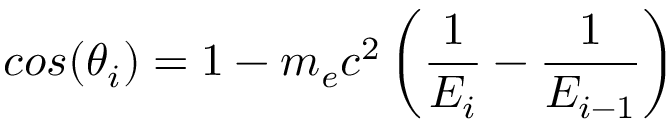<formula> <loc_0><loc_0><loc_500><loc_500>\cos ( \theta _ { i } ) = 1 - m _ { e } c ^ { 2 } \left ( \frac { 1 } { E _ { i } } - \frac { 1 } { E _ { i - 1 } } \right )</formula> 